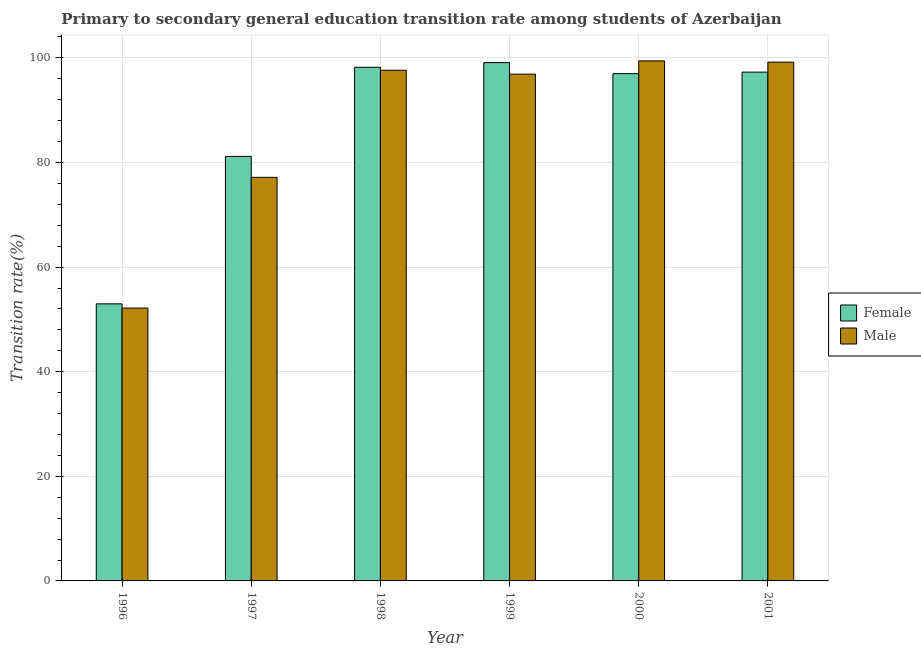How many different coloured bars are there?
Offer a very short reply. 2. How many groups of bars are there?
Keep it short and to the point. 6. Are the number of bars per tick equal to the number of legend labels?
Keep it short and to the point. Yes. Are the number of bars on each tick of the X-axis equal?
Your response must be concise. Yes. How many bars are there on the 1st tick from the left?
Your answer should be very brief. 2. How many bars are there on the 6th tick from the right?
Make the answer very short. 2. What is the label of the 1st group of bars from the left?
Keep it short and to the point. 1996. In how many cases, is the number of bars for a given year not equal to the number of legend labels?
Give a very brief answer. 0. What is the transition rate among male students in 1999?
Your answer should be very brief. 96.89. Across all years, what is the maximum transition rate among female students?
Your answer should be compact. 99.09. Across all years, what is the minimum transition rate among female students?
Your response must be concise. 52.98. In which year was the transition rate among female students minimum?
Offer a terse response. 1996. What is the total transition rate among female students in the graph?
Provide a succinct answer. 525.71. What is the difference between the transition rate among male students in 1999 and that in 2001?
Your answer should be very brief. -2.3. What is the difference between the transition rate among male students in 2000 and the transition rate among female students in 1999?
Your answer should be very brief. 2.54. What is the average transition rate among female students per year?
Provide a short and direct response. 87.62. In how many years, is the transition rate among female students greater than 16 %?
Make the answer very short. 6. What is the ratio of the transition rate among female students in 1996 to that in 2000?
Your answer should be very brief. 0.55. Is the transition rate among male students in 1997 less than that in 2001?
Provide a succinct answer. Yes. Is the difference between the transition rate among male students in 1996 and 1999 greater than the difference between the transition rate among female students in 1996 and 1999?
Offer a terse response. No. What is the difference between the highest and the second highest transition rate among female students?
Offer a terse response. 0.88. What is the difference between the highest and the lowest transition rate among female students?
Your answer should be very brief. 46.12. Is the sum of the transition rate among male students in 1998 and 2001 greater than the maximum transition rate among female students across all years?
Give a very brief answer. Yes. What does the 1st bar from the left in 2001 represents?
Your response must be concise. Female. How many years are there in the graph?
Keep it short and to the point. 6. What is the difference between two consecutive major ticks on the Y-axis?
Your response must be concise. 20. How many legend labels are there?
Offer a terse response. 2. What is the title of the graph?
Offer a very short reply. Primary to secondary general education transition rate among students of Azerbaijan. Does "Commercial bank branches" appear as one of the legend labels in the graph?
Offer a very short reply. No. What is the label or title of the X-axis?
Your answer should be compact. Year. What is the label or title of the Y-axis?
Your answer should be compact. Transition rate(%). What is the Transition rate(%) of Female in 1996?
Your answer should be compact. 52.98. What is the Transition rate(%) of Male in 1996?
Your answer should be very brief. 52.17. What is the Transition rate(%) in Female in 1997?
Make the answer very short. 81.17. What is the Transition rate(%) in Male in 1997?
Give a very brief answer. 77.16. What is the Transition rate(%) in Female in 1998?
Provide a succinct answer. 98.21. What is the Transition rate(%) in Male in 1998?
Your answer should be compact. 97.64. What is the Transition rate(%) of Female in 1999?
Offer a very short reply. 99.09. What is the Transition rate(%) of Male in 1999?
Give a very brief answer. 96.89. What is the Transition rate(%) in Female in 2000?
Your answer should be compact. 96.99. What is the Transition rate(%) of Male in 2000?
Make the answer very short. 99.43. What is the Transition rate(%) in Female in 2001?
Your response must be concise. 97.28. What is the Transition rate(%) in Male in 2001?
Your response must be concise. 99.19. Across all years, what is the maximum Transition rate(%) of Female?
Provide a succinct answer. 99.09. Across all years, what is the maximum Transition rate(%) of Male?
Your response must be concise. 99.43. Across all years, what is the minimum Transition rate(%) of Female?
Make the answer very short. 52.98. Across all years, what is the minimum Transition rate(%) of Male?
Give a very brief answer. 52.17. What is the total Transition rate(%) of Female in the graph?
Your answer should be compact. 525.71. What is the total Transition rate(%) of Male in the graph?
Make the answer very short. 522.49. What is the difference between the Transition rate(%) in Female in 1996 and that in 1997?
Give a very brief answer. -28.19. What is the difference between the Transition rate(%) of Male in 1996 and that in 1997?
Provide a succinct answer. -25. What is the difference between the Transition rate(%) of Female in 1996 and that in 1998?
Give a very brief answer. -45.23. What is the difference between the Transition rate(%) of Male in 1996 and that in 1998?
Provide a succinct answer. -45.48. What is the difference between the Transition rate(%) of Female in 1996 and that in 1999?
Keep it short and to the point. -46.12. What is the difference between the Transition rate(%) in Male in 1996 and that in 1999?
Your answer should be compact. -44.73. What is the difference between the Transition rate(%) in Female in 1996 and that in 2000?
Your answer should be very brief. -44.02. What is the difference between the Transition rate(%) of Male in 1996 and that in 2000?
Ensure brevity in your answer.  -47.26. What is the difference between the Transition rate(%) of Female in 1996 and that in 2001?
Ensure brevity in your answer.  -44.3. What is the difference between the Transition rate(%) in Male in 1996 and that in 2001?
Your answer should be compact. -47.02. What is the difference between the Transition rate(%) of Female in 1997 and that in 1998?
Your answer should be compact. -17.04. What is the difference between the Transition rate(%) in Male in 1997 and that in 1998?
Your answer should be compact. -20.48. What is the difference between the Transition rate(%) in Female in 1997 and that in 1999?
Provide a short and direct response. -17.93. What is the difference between the Transition rate(%) in Male in 1997 and that in 1999?
Provide a succinct answer. -19.73. What is the difference between the Transition rate(%) in Female in 1997 and that in 2000?
Make the answer very short. -15.83. What is the difference between the Transition rate(%) of Male in 1997 and that in 2000?
Keep it short and to the point. -22.27. What is the difference between the Transition rate(%) of Female in 1997 and that in 2001?
Give a very brief answer. -16.11. What is the difference between the Transition rate(%) of Male in 1997 and that in 2001?
Offer a terse response. -22.03. What is the difference between the Transition rate(%) of Female in 1998 and that in 1999?
Your answer should be compact. -0.88. What is the difference between the Transition rate(%) in Male in 1998 and that in 1999?
Make the answer very short. 0.75. What is the difference between the Transition rate(%) in Female in 1998 and that in 2000?
Your answer should be very brief. 1.22. What is the difference between the Transition rate(%) in Male in 1998 and that in 2000?
Keep it short and to the point. -1.79. What is the difference between the Transition rate(%) in Female in 1998 and that in 2001?
Your answer should be very brief. 0.93. What is the difference between the Transition rate(%) in Male in 1998 and that in 2001?
Give a very brief answer. -1.55. What is the difference between the Transition rate(%) in Female in 1999 and that in 2000?
Offer a terse response. 2.1. What is the difference between the Transition rate(%) in Male in 1999 and that in 2000?
Make the answer very short. -2.54. What is the difference between the Transition rate(%) of Female in 1999 and that in 2001?
Give a very brief answer. 1.81. What is the difference between the Transition rate(%) in Male in 1999 and that in 2001?
Ensure brevity in your answer.  -2.3. What is the difference between the Transition rate(%) in Female in 2000 and that in 2001?
Offer a very short reply. -0.29. What is the difference between the Transition rate(%) of Male in 2000 and that in 2001?
Your answer should be compact. 0.24. What is the difference between the Transition rate(%) in Female in 1996 and the Transition rate(%) in Male in 1997?
Offer a terse response. -24.19. What is the difference between the Transition rate(%) of Female in 1996 and the Transition rate(%) of Male in 1998?
Provide a short and direct response. -44.67. What is the difference between the Transition rate(%) in Female in 1996 and the Transition rate(%) in Male in 1999?
Your response must be concise. -43.92. What is the difference between the Transition rate(%) in Female in 1996 and the Transition rate(%) in Male in 2000?
Offer a terse response. -46.45. What is the difference between the Transition rate(%) of Female in 1996 and the Transition rate(%) of Male in 2001?
Provide a short and direct response. -46.22. What is the difference between the Transition rate(%) of Female in 1997 and the Transition rate(%) of Male in 1998?
Provide a short and direct response. -16.48. What is the difference between the Transition rate(%) in Female in 1997 and the Transition rate(%) in Male in 1999?
Your response must be concise. -15.73. What is the difference between the Transition rate(%) in Female in 1997 and the Transition rate(%) in Male in 2000?
Offer a terse response. -18.27. What is the difference between the Transition rate(%) of Female in 1997 and the Transition rate(%) of Male in 2001?
Provide a succinct answer. -18.03. What is the difference between the Transition rate(%) of Female in 1998 and the Transition rate(%) of Male in 1999?
Give a very brief answer. 1.32. What is the difference between the Transition rate(%) in Female in 1998 and the Transition rate(%) in Male in 2000?
Your response must be concise. -1.22. What is the difference between the Transition rate(%) in Female in 1998 and the Transition rate(%) in Male in 2001?
Give a very brief answer. -0.98. What is the difference between the Transition rate(%) of Female in 1999 and the Transition rate(%) of Male in 2000?
Offer a terse response. -0.34. What is the difference between the Transition rate(%) in Female in 1999 and the Transition rate(%) in Male in 2001?
Keep it short and to the point. -0.1. What is the difference between the Transition rate(%) of Female in 2000 and the Transition rate(%) of Male in 2001?
Make the answer very short. -2.2. What is the average Transition rate(%) of Female per year?
Your answer should be compact. 87.62. What is the average Transition rate(%) in Male per year?
Provide a short and direct response. 87.08. In the year 1996, what is the difference between the Transition rate(%) in Female and Transition rate(%) in Male?
Offer a terse response. 0.81. In the year 1997, what is the difference between the Transition rate(%) of Female and Transition rate(%) of Male?
Provide a short and direct response. 4. In the year 1998, what is the difference between the Transition rate(%) of Female and Transition rate(%) of Male?
Give a very brief answer. 0.57. In the year 1999, what is the difference between the Transition rate(%) in Female and Transition rate(%) in Male?
Your answer should be compact. 2.2. In the year 2000, what is the difference between the Transition rate(%) in Female and Transition rate(%) in Male?
Provide a succinct answer. -2.44. In the year 2001, what is the difference between the Transition rate(%) of Female and Transition rate(%) of Male?
Your response must be concise. -1.91. What is the ratio of the Transition rate(%) of Female in 1996 to that in 1997?
Provide a succinct answer. 0.65. What is the ratio of the Transition rate(%) of Male in 1996 to that in 1997?
Your response must be concise. 0.68. What is the ratio of the Transition rate(%) in Female in 1996 to that in 1998?
Your answer should be very brief. 0.54. What is the ratio of the Transition rate(%) in Male in 1996 to that in 1998?
Provide a short and direct response. 0.53. What is the ratio of the Transition rate(%) in Female in 1996 to that in 1999?
Ensure brevity in your answer.  0.53. What is the ratio of the Transition rate(%) in Male in 1996 to that in 1999?
Provide a short and direct response. 0.54. What is the ratio of the Transition rate(%) in Female in 1996 to that in 2000?
Ensure brevity in your answer.  0.55. What is the ratio of the Transition rate(%) in Male in 1996 to that in 2000?
Your answer should be compact. 0.52. What is the ratio of the Transition rate(%) of Female in 1996 to that in 2001?
Your response must be concise. 0.54. What is the ratio of the Transition rate(%) of Male in 1996 to that in 2001?
Provide a succinct answer. 0.53. What is the ratio of the Transition rate(%) of Female in 1997 to that in 1998?
Offer a very short reply. 0.83. What is the ratio of the Transition rate(%) in Male in 1997 to that in 1998?
Offer a terse response. 0.79. What is the ratio of the Transition rate(%) of Female in 1997 to that in 1999?
Keep it short and to the point. 0.82. What is the ratio of the Transition rate(%) of Male in 1997 to that in 1999?
Keep it short and to the point. 0.8. What is the ratio of the Transition rate(%) in Female in 1997 to that in 2000?
Your answer should be compact. 0.84. What is the ratio of the Transition rate(%) of Male in 1997 to that in 2000?
Keep it short and to the point. 0.78. What is the ratio of the Transition rate(%) of Female in 1997 to that in 2001?
Your answer should be very brief. 0.83. What is the ratio of the Transition rate(%) of Male in 1997 to that in 2001?
Your answer should be very brief. 0.78. What is the ratio of the Transition rate(%) in Female in 1998 to that in 1999?
Keep it short and to the point. 0.99. What is the ratio of the Transition rate(%) of Male in 1998 to that in 1999?
Make the answer very short. 1.01. What is the ratio of the Transition rate(%) in Female in 1998 to that in 2000?
Ensure brevity in your answer.  1.01. What is the ratio of the Transition rate(%) in Female in 1998 to that in 2001?
Your answer should be compact. 1.01. What is the ratio of the Transition rate(%) in Male in 1998 to that in 2001?
Your answer should be very brief. 0.98. What is the ratio of the Transition rate(%) of Female in 1999 to that in 2000?
Your answer should be very brief. 1.02. What is the ratio of the Transition rate(%) of Male in 1999 to that in 2000?
Provide a short and direct response. 0.97. What is the ratio of the Transition rate(%) in Female in 1999 to that in 2001?
Make the answer very short. 1.02. What is the ratio of the Transition rate(%) of Male in 1999 to that in 2001?
Offer a very short reply. 0.98. What is the difference between the highest and the second highest Transition rate(%) in Female?
Ensure brevity in your answer.  0.88. What is the difference between the highest and the second highest Transition rate(%) of Male?
Offer a terse response. 0.24. What is the difference between the highest and the lowest Transition rate(%) in Female?
Ensure brevity in your answer.  46.12. What is the difference between the highest and the lowest Transition rate(%) in Male?
Ensure brevity in your answer.  47.26. 